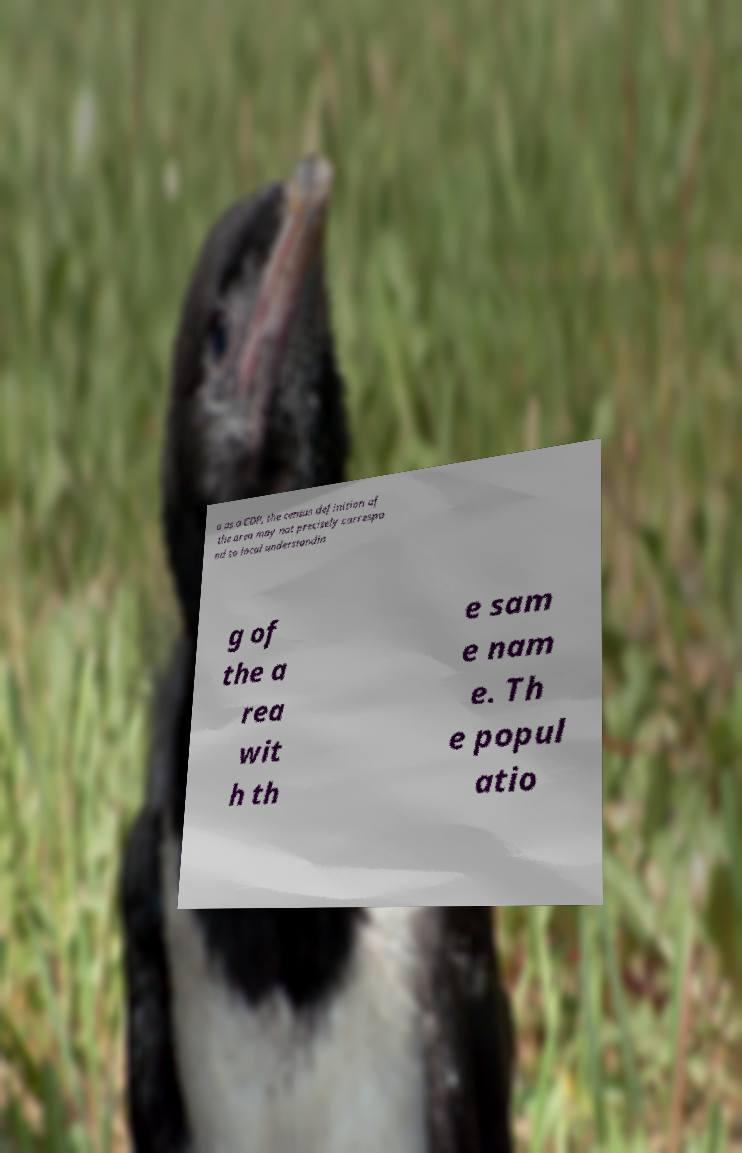What messages or text are displayed in this image? I need them in a readable, typed format. a as a CDP, the census definition of the area may not precisely correspo nd to local understandin g of the a rea wit h th e sam e nam e. Th e popul atio 